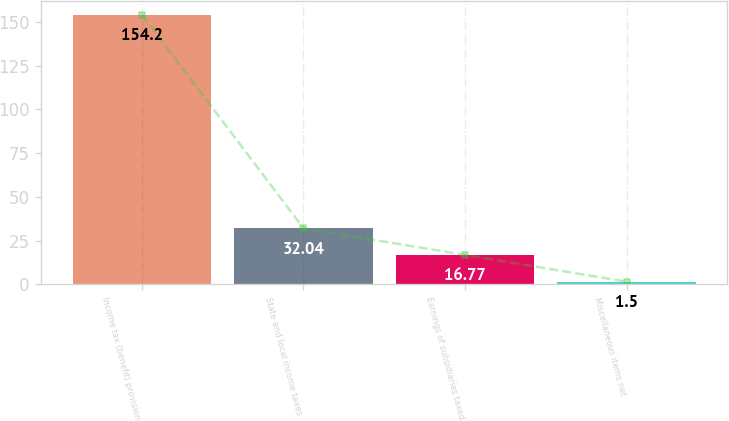Convert chart to OTSL. <chart><loc_0><loc_0><loc_500><loc_500><bar_chart><fcel>Income tax (benefit) provision<fcel>State and local income taxes<fcel>Earnings of subsidiaries taxed<fcel>Miscellaneous items net<nl><fcel>154.2<fcel>32.04<fcel>16.77<fcel>1.5<nl></chart> 